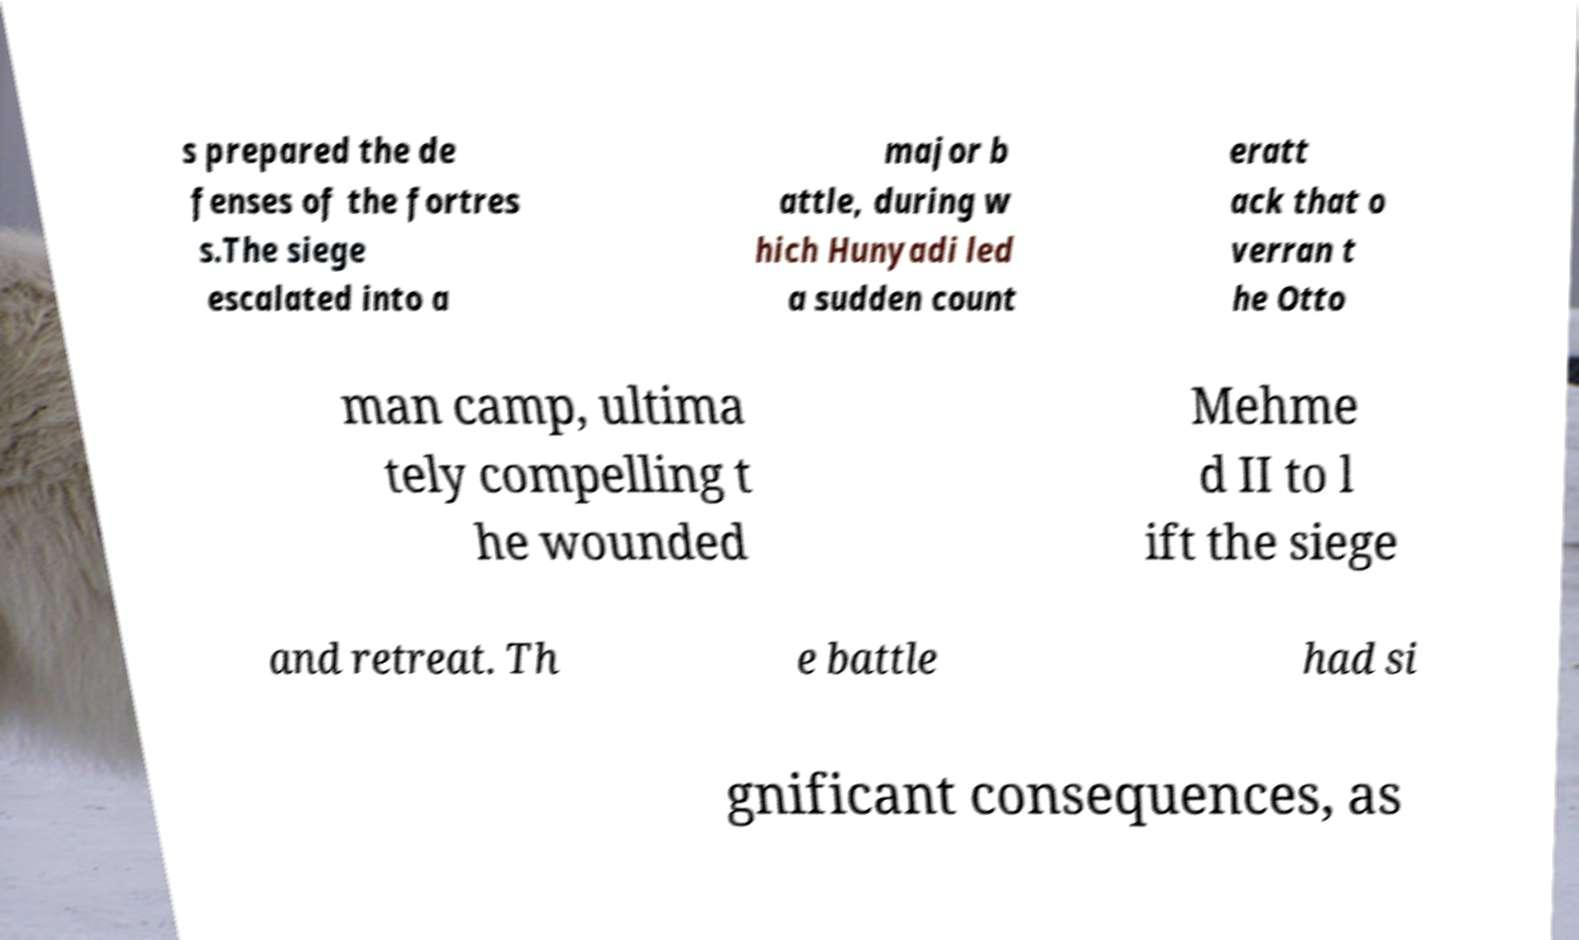Can you read and provide the text displayed in the image?This photo seems to have some interesting text. Can you extract and type it out for me? s prepared the de fenses of the fortres s.The siege escalated into a major b attle, during w hich Hunyadi led a sudden count eratt ack that o verran t he Otto man camp, ultima tely compelling t he wounded Mehme d II to l ift the siege and retreat. Th e battle had si gnificant consequences, as 